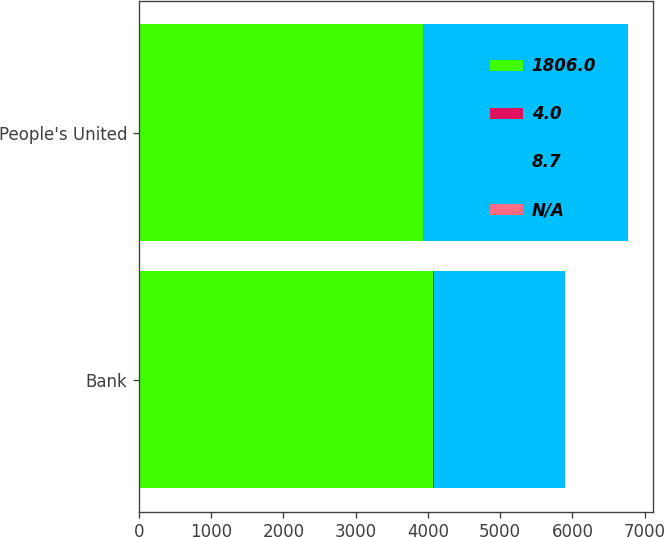Convert chart. <chart><loc_0><loc_0><loc_500><loc_500><stacked_bar_chart><ecel><fcel>Bank<fcel>People's United<nl><fcel>1806<fcel>4076<fcel>3927.2<nl><fcel>4<fcel>9<fcel>10.9<nl><fcel>8.7<fcel>1805.4<fcel>2827.9<nl><fcel>nan<fcel>4<fcel>7.88<nl></chart> 